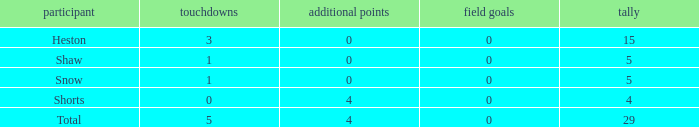What is the total number of field goals for a player that had less than 3 touchdowns, had 4 points, and had less than 4 extra points? 0.0. 